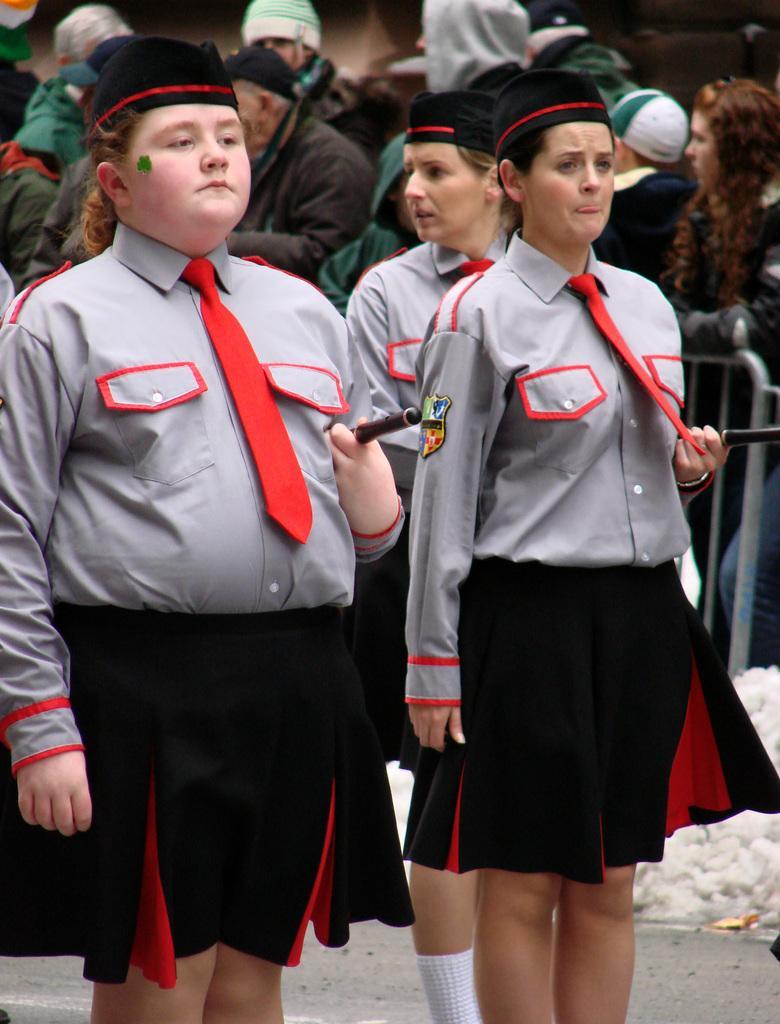Describe this image in one or two sentences. In this image there are three persons standing, and in the background there are group of people standing, and there is a barrier. 